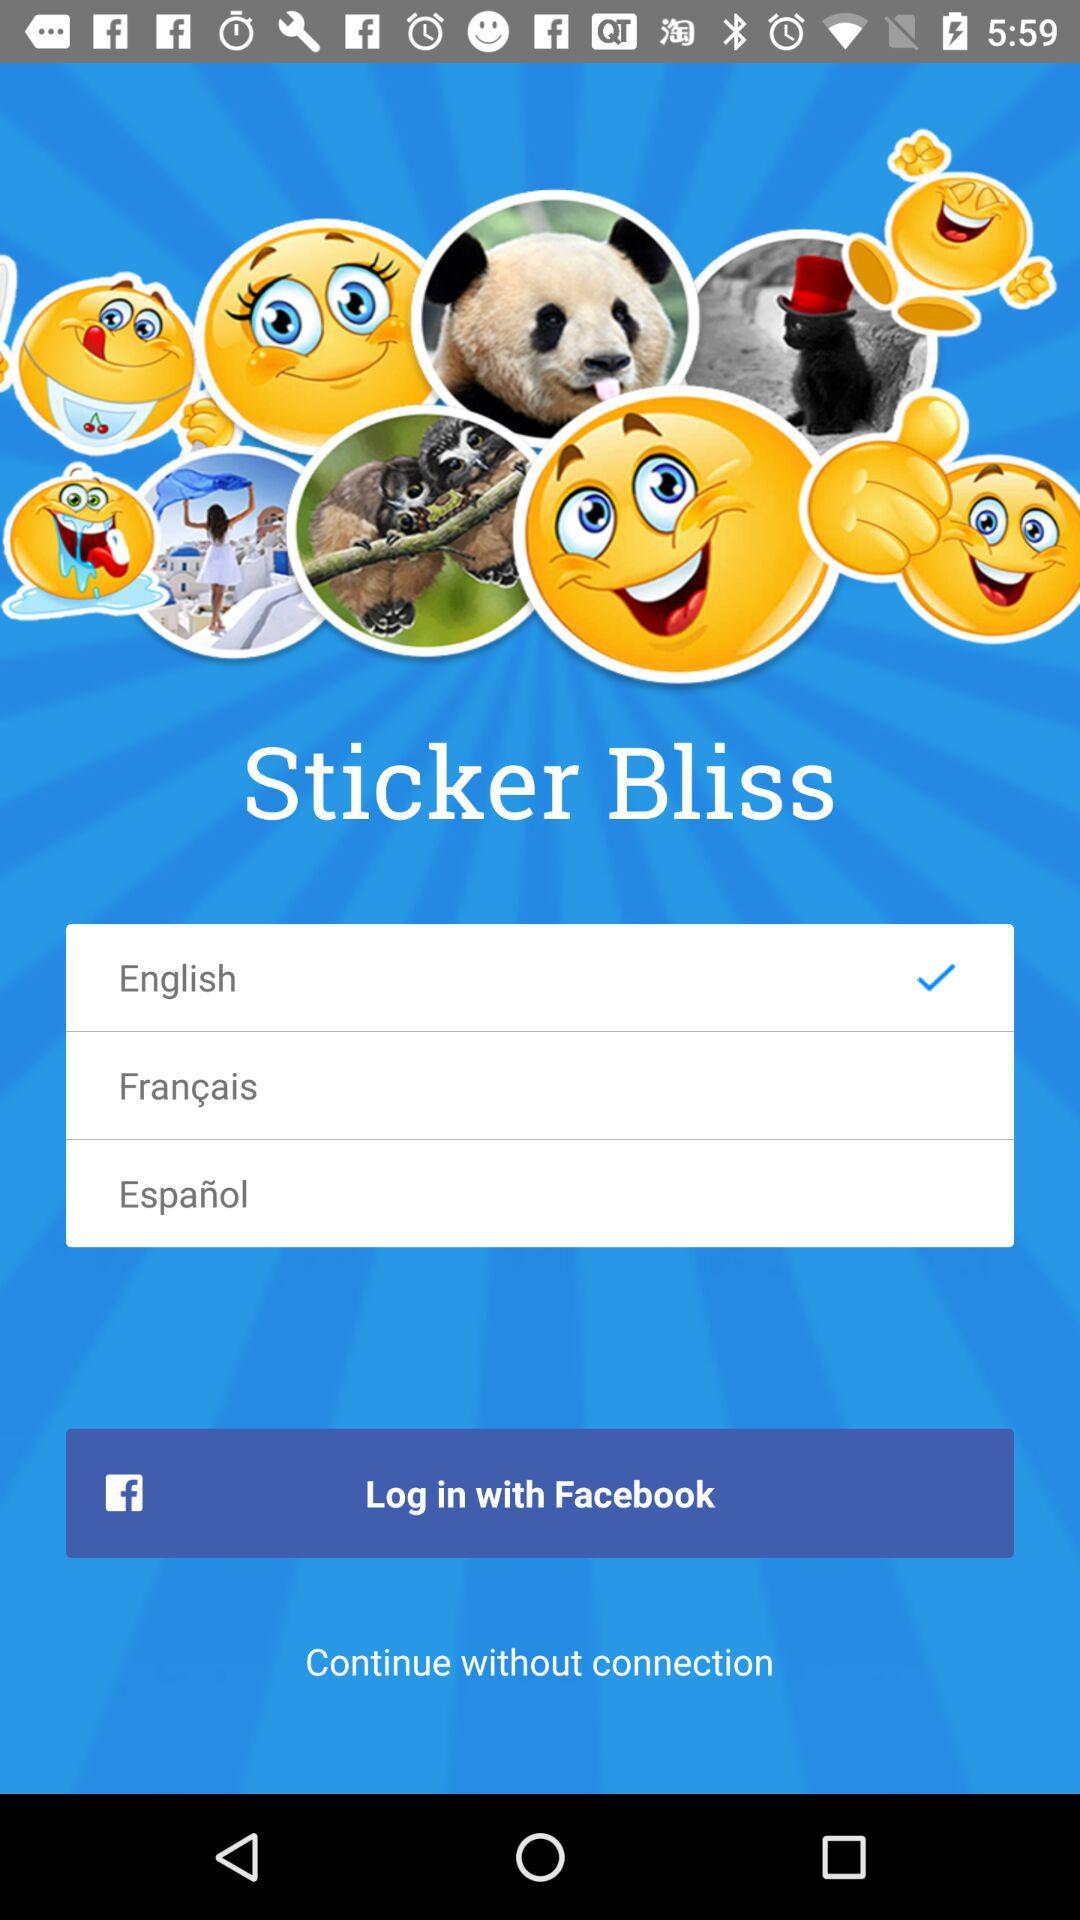How many languages are available to choose from?
Answer the question using a single word or phrase. 3 